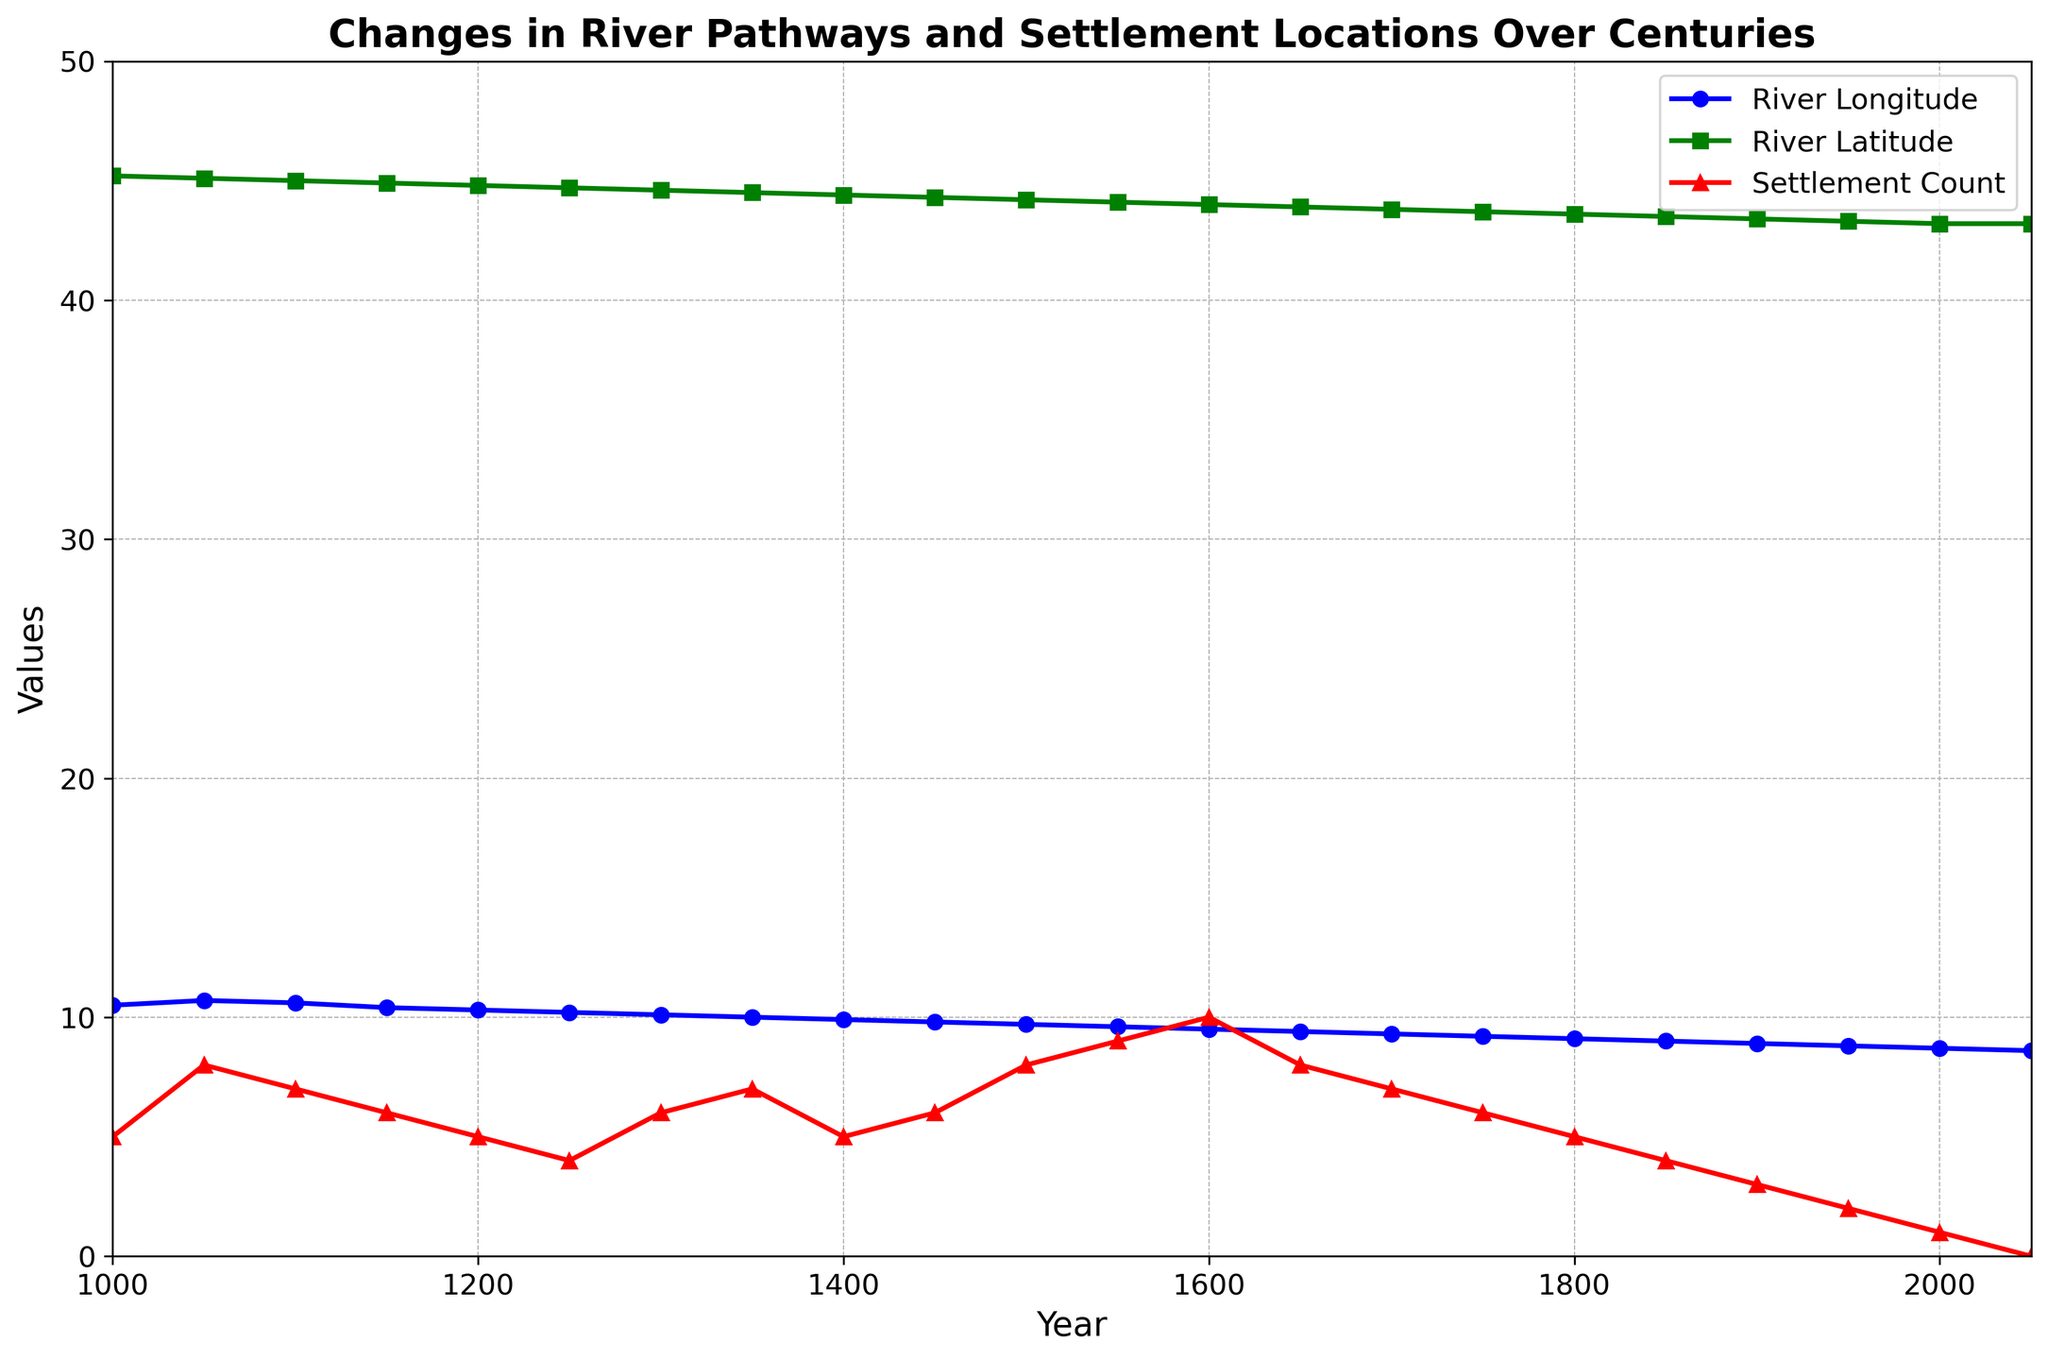What is the overall trend in the River Longitude from the year 1000 to 2050? The River Longitude shows a continuous decrease from 10.5 in the year 1000 to 8.6 in the year 2050. This signifies that the river has been shifting westward over the centuries.
Answer: Decreasing What is the year with the maximum Settlement Count? The maximum Settlement Count is 10, which occurs in the year 1600.
Answer: 1600 How does the Settlement Count in the year 1600 compare to that in the year 2000? The Settlement Count in the year 1600 is 10, while in the year 2000 it is 1. This indicates a substantial decline by 9 settlements over the 400 years.
Answer: Declines by 9 settlements During which interval does the River Latitude exhibit the sharpest decline? Observing the River Latitude trend, it shows the sharpest decline between the years 1000 (45.2) and 1050 (45.1) with a decrease of 0.1 per 50 years. However, all declines are fairly uniform around 0.1 per 50 years.
Answer: 1000 to 1050 Compare the River Latitude in the years 1300 and 1400 and determine by how much it changed. The River Latitude in 1300 is 44.6, and in 1400 it is 44.4. The change from 1300 to 1400 is 0.2 degrees.
Answer: 0.2 degrees What is the median Settlement Count over the entire duration from 1000 to 2050? To find the median, arrange the settlement counts in order: 0, 1, 2, 3, 4, 4, 5, 5, 5, 6, 6, 6, 7, 7, 8, 8, 9, 10. The middle value in this series is 6, so the median Settlement Count is 6.
Answer: 6 What is the relationship between River Longitude and Settlement Count in the 21st century? From the data, as River Longitude decreases from 8.9 in 1900 to 8.6 in 2050, the Settlement Count also decreases, from 3 in 1900 to 0 in 2050. This suggests a negative correlation.
Answer: Negative correlation In which century did the Settlement Count decrease the most drastically and by how much? Between the years 1850 (Settlement Count of 4) and 1950 (Settlement Count of 2), there is a decrease of 2 settlements. This century exhibits one of the most noticeable declines.
Answer: 19th to 20th century, by 2 settlements How does the Settlement Count change correspond to the changes in River Latitude over time? Generally, as the River Latitude consistently decreases from 45.2 to 43.2, the Settlement Count initially fluctuates, increases to a peak of 10 around the year 1600, and then decreases significantly by 2050. This suggests that settlements initially thrived with minor river movements but declined with continued shifts.
Answer: Peaks then declines Which had a more pronounced decrease from 1000 to 2050: River Longitude or River Latitude? The River Longitude decreased from 10.5 to 8.6, a change of 1.9 units, whereas the River Latitude decreased from 45.2 to 43.2, a change of 2 units. Thus, River Latitude had a slightly more pronounced decrease.
Answer: River Latitude 